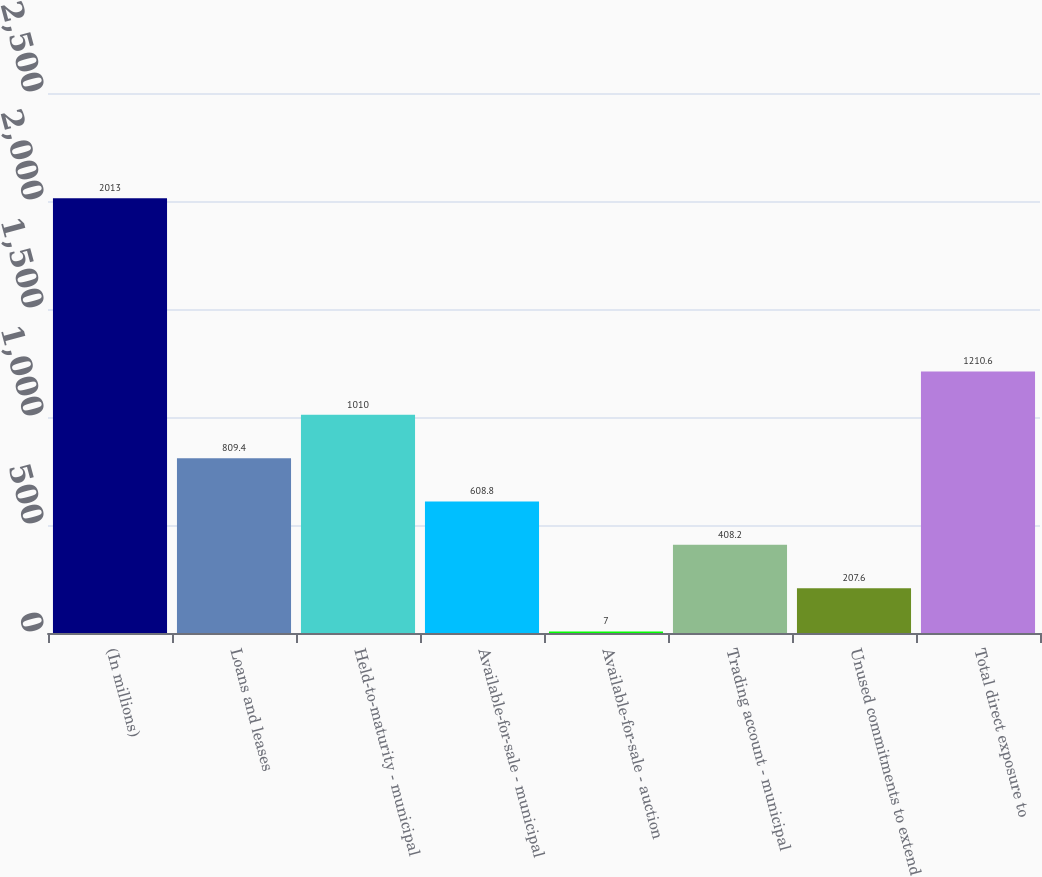Convert chart to OTSL. <chart><loc_0><loc_0><loc_500><loc_500><bar_chart><fcel>(In millions)<fcel>Loans and leases<fcel>Held-to-maturity - municipal<fcel>Available-for-sale - municipal<fcel>Available-for-sale - auction<fcel>Trading account - municipal<fcel>Unused commitments to extend<fcel>Total direct exposure to<nl><fcel>2013<fcel>809.4<fcel>1010<fcel>608.8<fcel>7<fcel>408.2<fcel>207.6<fcel>1210.6<nl></chart> 